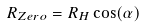<formula> <loc_0><loc_0><loc_500><loc_500>R _ { Z e r o } = R _ { H } \cos ( \alpha )</formula> 